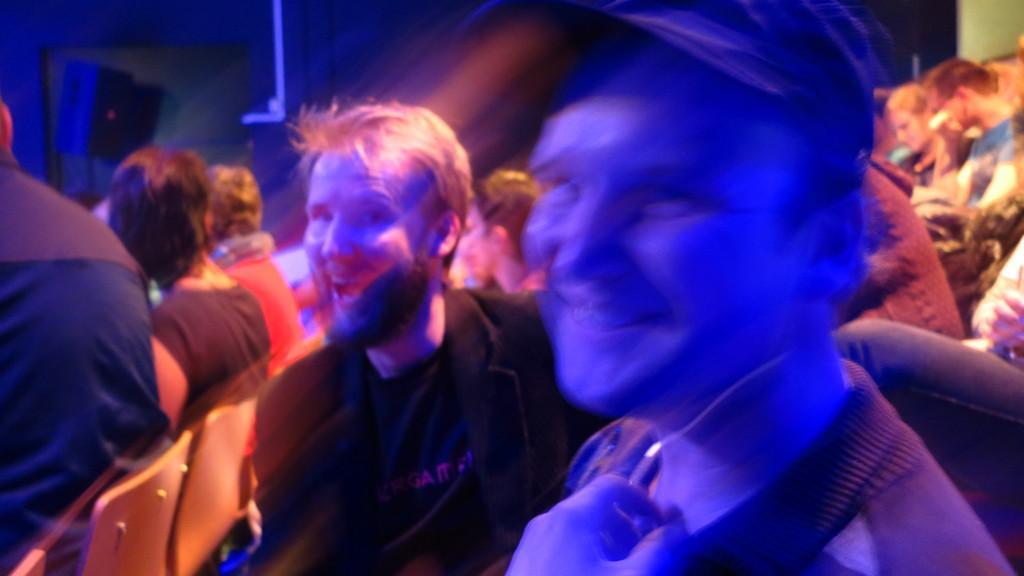Please provide a concise description of this image. In this picture, there is a man towards the right. He is wearing a cap. Beside him, there is another man wearing black blazer and black t shirt. Towards the left, there are people sitting on the chairs. Towards the right corner, there are some more people. 